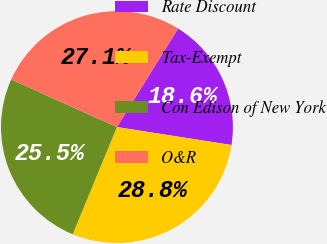Convert chart. <chart><loc_0><loc_0><loc_500><loc_500><pie_chart><fcel>Rate Discount<fcel>Tax-Exempt<fcel>Con Edison of New York<fcel>O&R<nl><fcel>18.63%<fcel>28.76%<fcel>25.49%<fcel>27.12%<nl></chart> 